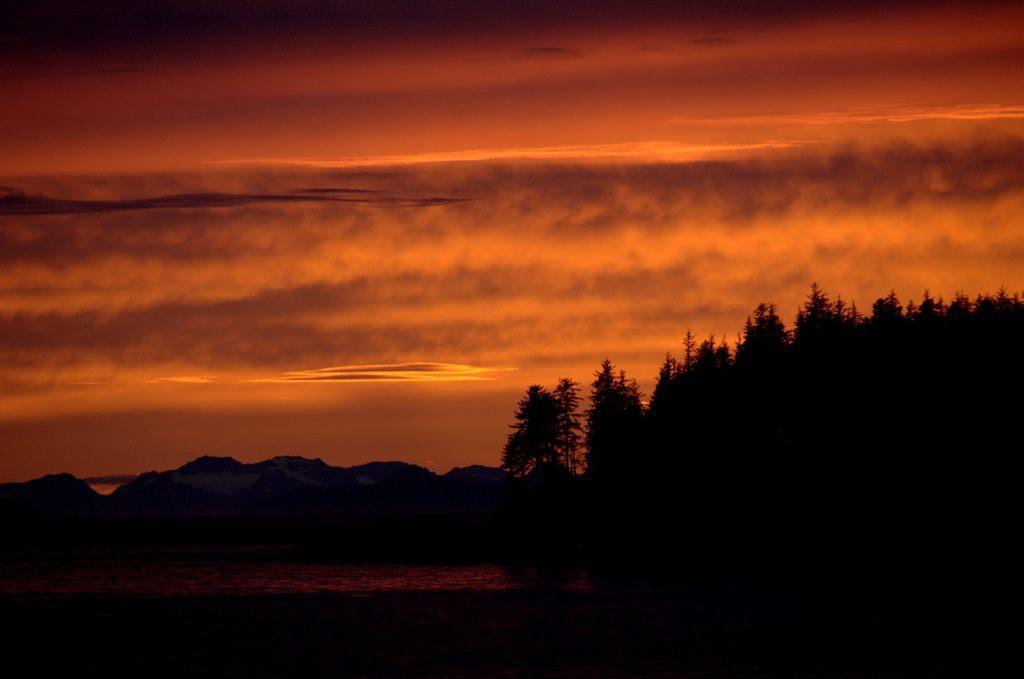Could you give a brief overview of what you see in this image? In the picture I can see trees. In the background I can see the sky. 